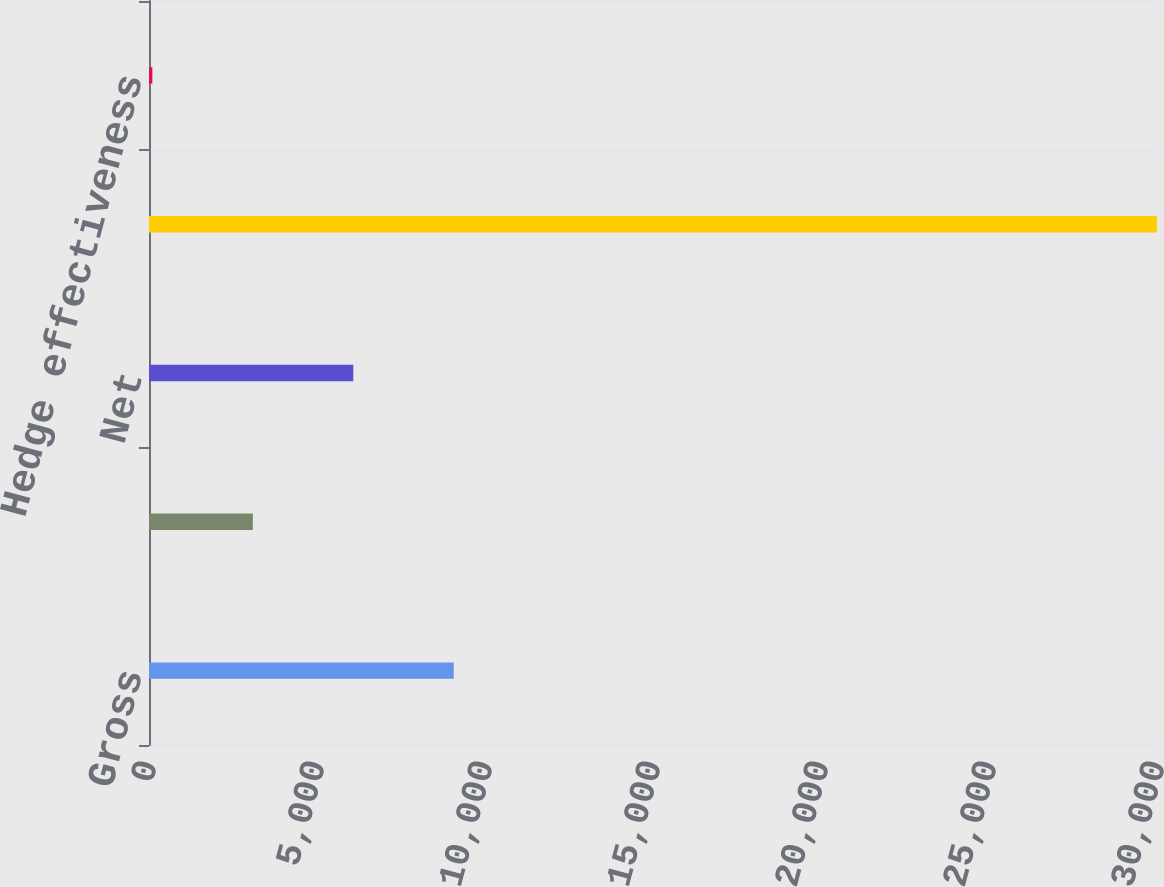Convert chart to OTSL. <chart><loc_0><loc_0><loc_500><loc_500><bar_chart><fcel>Gross<fcel>Income tax (benefit)<fcel>Net<fcel>Notional balance of<fcel>Hedge effectiveness<nl><fcel>9070<fcel>3090<fcel>6080<fcel>30000<fcel>100<nl></chart> 